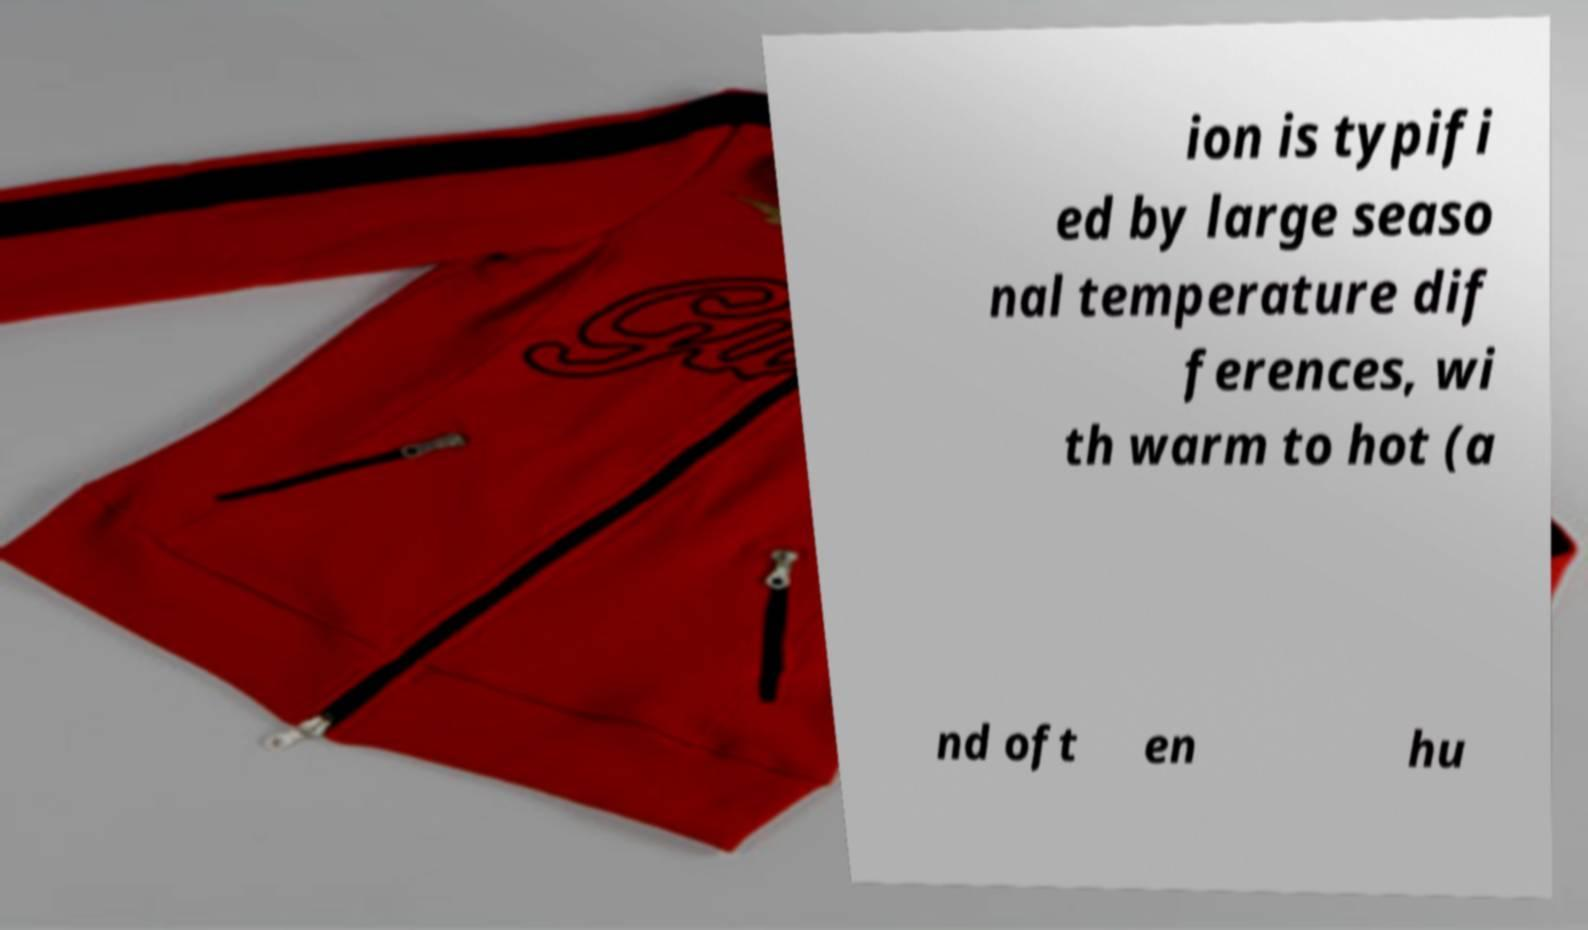Could you extract and type out the text from this image? ion is typifi ed by large seaso nal temperature dif ferences, wi th warm to hot (a nd oft en hu 